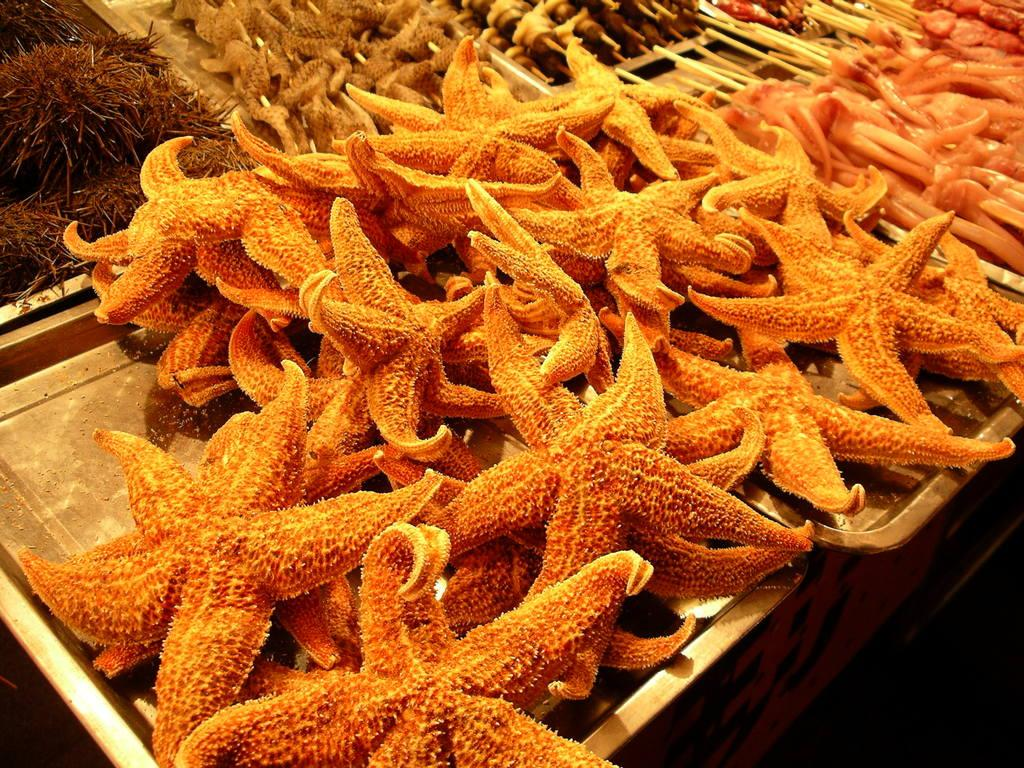What type of sea creature can be seen in the image? There are starfishes in the image. What else is present in the image besides starfishes? There are other types of meat in the image. How are the different types of meat arranged? The meat is arranged on trays. What is the color of the background in the image? The background of the image is dark in color. What type of record can be seen in the image? There is no record present in the image. How much sugar is used in the preparation of the meat in the image? There is no information about sugar or its use in the preparation of the meat in the image. 